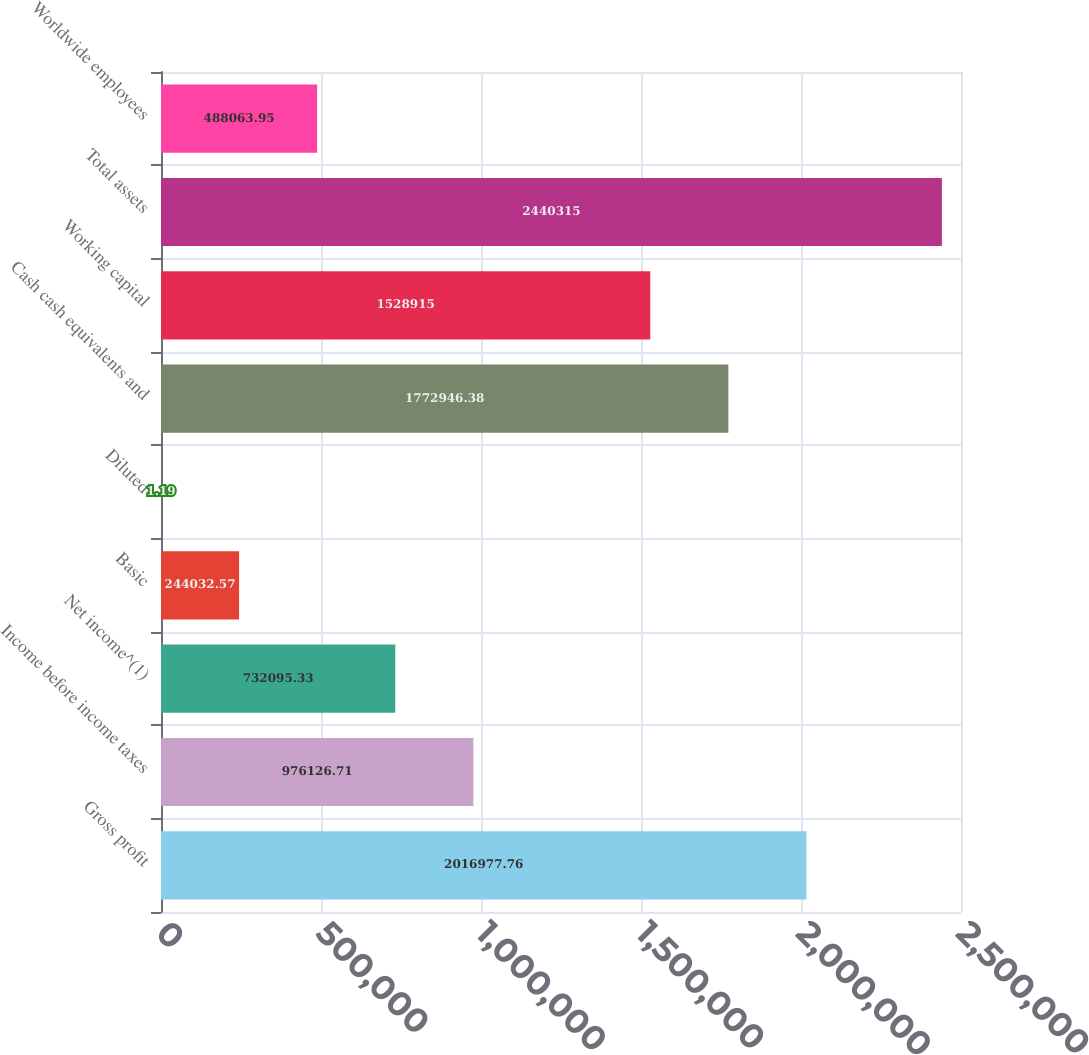Convert chart to OTSL. <chart><loc_0><loc_0><loc_500><loc_500><bar_chart><fcel>Gross profit<fcel>Income before income taxes<fcel>Net income^(1)<fcel>Basic<fcel>Diluted<fcel>Cash cash equivalents and<fcel>Working capital<fcel>Total assets<fcel>Worldwide employees<nl><fcel>2.01698e+06<fcel>976127<fcel>732095<fcel>244033<fcel>1.19<fcel>1.77295e+06<fcel>1.52892e+06<fcel>2.44032e+06<fcel>488064<nl></chart> 